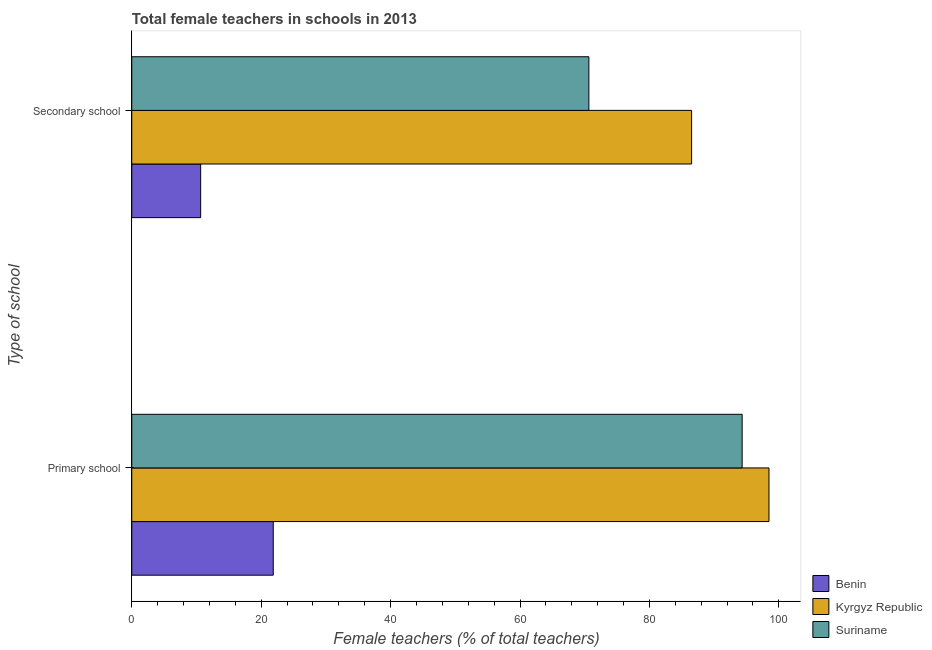How many different coloured bars are there?
Give a very brief answer. 3. How many groups of bars are there?
Ensure brevity in your answer.  2. How many bars are there on the 2nd tick from the bottom?
Your answer should be very brief. 3. What is the label of the 1st group of bars from the top?
Ensure brevity in your answer.  Secondary school. What is the percentage of female teachers in primary schools in Kyrgyz Republic?
Keep it short and to the point. 98.48. Across all countries, what is the maximum percentage of female teachers in primary schools?
Your response must be concise. 98.48. Across all countries, what is the minimum percentage of female teachers in secondary schools?
Your answer should be compact. 10.65. In which country was the percentage of female teachers in primary schools maximum?
Ensure brevity in your answer.  Kyrgyz Republic. In which country was the percentage of female teachers in secondary schools minimum?
Keep it short and to the point. Benin. What is the total percentage of female teachers in primary schools in the graph?
Keep it short and to the point. 214.67. What is the difference between the percentage of female teachers in primary schools in Suriname and that in Benin?
Ensure brevity in your answer.  72.46. What is the difference between the percentage of female teachers in primary schools in Benin and the percentage of female teachers in secondary schools in Kyrgyz Republic?
Offer a terse response. -64.65. What is the average percentage of female teachers in primary schools per country?
Provide a short and direct response. 71.56. What is the difference between the percentage of female teachers in primary schools and percentage of female teachers in secondary schools in Benin?
Ensure brevity in your answer.  11.22. In how many countries, is the percentage of female teachers in primary schools greater than 56 %?
Provide a succinct answer. 2. What is the ratio of the percentage of female teachers in primary schools in Suriname to that in Kyrgyz Republic?
Provide a short and direct response. 0.96. Is the percentage of female teachers in primary schools in Suriname less than that in Benin?
Ensure brevity in your answer.  No. What does the 1st bar from the top in Secondary school represents?
Offer a terse response. Suriname. What does the 2nd bar from the bottom in Primary school represents?
Give a very brief answer. Kyrgyz Republic. How many bars are there?
Your response must be concise. 6. Are all the bars in the graph horizontal?
Provide a succinct answer. Yes. How many countries are there in the graph?
Offer a very short reply. 3. What is the difference between two consecutive major ticks on the X-axis?
Your answer should be compact. 20. Does the graph contain any zero values?
Ensure brevity in your answer.  No. Does the graph contain grids?
Your answer should be very brief. No. What is the title of the graph?
Your answer should be compact. Total female teachers in schools in 2013. What is the label or title of the X-axis?
Ensure brevity in your answer.  Female teachers (% of total teachers). What is the label or title of the Y-axis?
Your answer should be very brief. Type of school. What is the Female teachers (% of total teachers) of Benin in Primary school?
Offer a very short reply. 21.87. What is the Female teachers (% of total teachers) of Kyrgyz Republic in Primary school?
Offer a terse response. 98.48. What is the Female teachers (% of total teachers) of Suriname in Primary school?
Give a very brief answer. 94.33. What is the Female teachers (% of total teachers) of Benin in Secondary school?
Offer a very short reply. 10.65. What is the Female teachers (% of total teachers) in Kyrgyz Republic in Secondary school?
Make the answer very short. 86.52. What is the Female teachers (% of total teachers) in Suriname in Secondary school?
Provide a short and direct response. 70.64. Across all Type of school, what is the maximum Female teachers (% of total teachers) in Benin?
Offer a very short reply. 21.87. Across all Type of school, what is the maximum Female teachers (% of total teachers) in Kyrgyz Republic?
Keep it short and to the point. 98.48. Across all Type of school, what is the maximum Female teachers (% of total teachers) of Suriname?
Your answer should be very brief. 94.33. Across all Type of school, what is the minimum Female teachers (% of total teachers) of Benin?
Provide a short and direct response. 10.65. Across all Type of school, what is the minimum Female teachers (% of total teachers) of Kyrgyz Republic?
Your response must be concise. 86.52. Across all Type of school, what is the minimum Female teachers (% of total teachers) of Suriname?
Provide a short and direct response. 70.64. What is the total Female teachers (% of total teachers) of Benin in the graph?
Your response must be concise. 32.51. What is the total Female teachers (% of total teachers) of Kyrgyz Republic in the graph?
Your response must be concise. 184.99. What is the total Female teachers (% of total teachers) of Suriname in the graph?
Make the answer very short. 164.97. What is the difference between the Female teachers (% of total teachers) in Benin in Primary school and that in Secondary school?
Provide a succinct answer. 11.22. What is the difference between the Female teachers (% of total teachers) of Kyrgyz Republic in Primary school and that in Secondary school?
Your answer should be compact. 11.96. What is the difference between the Female teachers (% of total teachers) of Suriname in Primary school and that in Secondary school?
Provide a short and direct response. 23.69. What is the difference between the Female teachers (% of total teachers) in Benin in Primary school and the Female teachers (% of total teachers) in Kyrgyz Republic in Secondary school?
Your response must be concise. -64.65. What is the difference between the Female teachers (% of total teachers) in Benin in Primary school and the Female teachers (% of total teachers) in Suriname in Secondary school?
Offer a very short reply. -48.78. What is the difference between the Female teachers (% of total teachers) in Kyrgyz Republic in Primary school and the Female teachers (% of total teachers) in Suriname in Secondary school?
Provide a succinct answer. 27.84. What is the average Female teachers (% of total teachers) in Benin per Type of school?
Ensure brevity in your answer.  16.26. What is the average Female teachers (% of total teachers) in Kyrgyz Republic per Type of school?
Your response must be concise. 92.5. What is the average Female teachers (% of total teachers) of Suriname per Type of school?
Your response must be concise. 82.48. What is the difference between the Female teachers (% of total teachers) in Benin and Female teachers (% of total teachers) in Kyrgyz Republic in Primary school?
Provide a succinct answer. -76.61. What is the difference between the Female teachers (% of total teachers) in Benin and Female teachers (% of total teachers) in Suriname in Primary school?
Your answer should be compact. -72.46. What is the difference between the Female teachers (% of total teachers) of Kyrgyz Republic and Female teachers (% of total teachers) of Suriname in Primary school?
Make the answer very short. 4.15. What is the difference between the Female teachers (% of total teachers) in Benin and Female teachers (% of total teachers) in Kyrgyz Republic in Secondary school?
Give a very brief answer. -75.87. What is the difference between the Female teachers (% of total teachers) of Benin and Female teachers (% of total teachers) of Suriname in Secondary school?
Ensure brevity in your answer.  -59.99. What is the difference between the Female teachers (% of total teachers) in Kyrgyz Republic and Female teachers (% of total teachers) in Suriname in Secondary school?
Make the answer very short. 15.88. What is the ratio of the Female teachers (% of total teachers) in Benin in Primary school to that in Secondary school?
Ensure brevity in your answer.  2.05. What is the ratio of the Female teachers (% of total teachers) in Kyrgyz Republic in Primary school to that in Secondary school?
Make the answer very short. 1.14. What is the ratio of the Female teachers (% of total teachers) of Suriname in Primary school to that in Secondary school?
Offer a terse response. 1.34. What is the difference between the highest and the second highest Female teachers (% of total teachers) of Benin?
Ensure brevity in your answer.  11.22. What is the difference between the highest and the second highest Female teachers (% of total teachers) of Kyrgyz Republic?
Offer a terse response. 11.96. What is the difference between the highest and the second highest Female teachers (% of total teachers) in Suriname?
Offer a very short reply. 23.69. What is the difference between the highest and the lowest Female teachers (% of total teachers) in Benin?
Your response must be concise. 11.22. What is the difference between the highest and the lowest Female teachers (% of total teachers) of Kyrgyz Republic?
Provide a short and direct response. 11.96. What is the difference between the highest and the lowest Female teachers (% of total teachers) in Suriname?
Give a very brief answer. 23.69. 